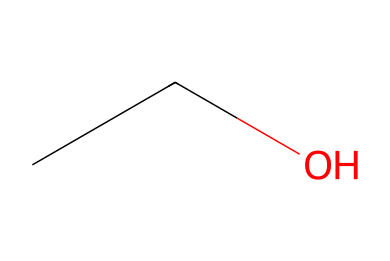How many carbon atoms are in ethanol? The SMILES representation "CCO" indicates that there are two carbon atoms present in the structure, as "C" corresponds to each carbon atom.
Answer: 2 What type of functional group is present in ethanol? The presence of "O" linked to "C" suggests that there is a hydroxyl (-OH) functional group in ethanol, characteristic of alcohols.
Answer: hydroxyl How many hydrogen atoms are in ethanol? By analyzing the structure "CCO", each carbon typically forms four bonds. With two carbons (2C) and one oxygen (1O), the total number of hydrogen atoms can be inferred: 6 (C2H6) minus the bond taken up by the OH group results in 6 - 1 = 5.
Answer: 6 What class of compounds does ethanol belong to? Ethanol, represented by the structure "CCO", is recognized as an alcohol due to its functional group (hydroxyl), making it part of the alcohol class of compounds.
Answer: alcohol Is ethanol a saturated or unsaturated compound? With no double or triple bonds present in the "CCO" structure, ethanol is considered saturated because all carbon atoms are fully bonded with hydrogen atoms.
Answer: saturated 